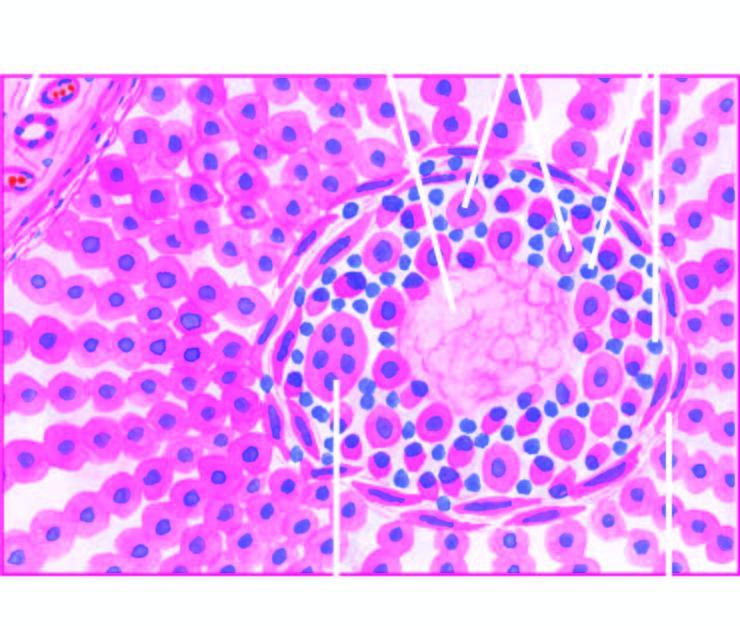what is central coagulative necrosis surrounded by?
Answer the question using a single word or phrase. Palisades of macrophages and plasma cells marginated peripherally by fibroblasts 